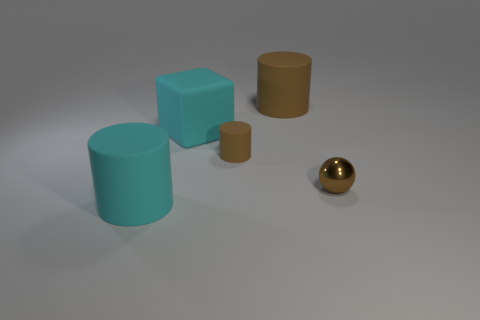Add 4 cylinders. How many objects exist? 9 Subtract all big cylinders. How many cylinders are left? 1 Add 3 blocks. How many blocks exist? 4 Subtract all brown cylinders. How many cylinders are left? 1 Subtract 1 cyan blocks. How many objects are left? 4 Subtract all cylinders. How many objects are left? 2 Subtract 1 balls. How many balls are left? 0 Subtract all blue blocks. Subtract all yellow cylinders. How many blocks are left? 1 Subtract all brown balls. How many red cylinders are left? 0 Subtract all big rubber cylinders. Subtract all large rubber cylinders. How many objects are left? 1 